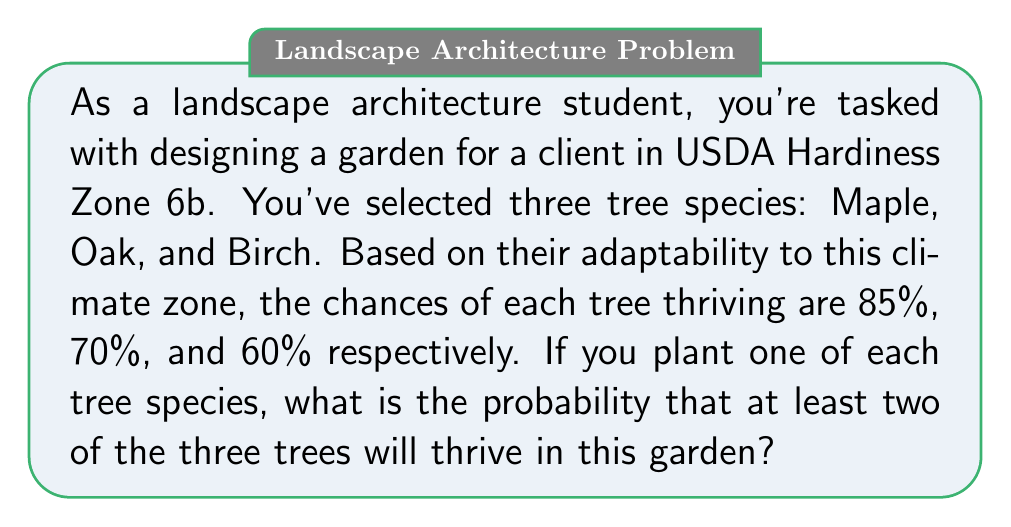Can you solve this math problem? Let's approach this step-by-step:

1) First, we need to calculate the probability of at least two trees thriving. It's easier to calculate this by subtracting the probability of 0 or 1 tree thriving from 1.

2) Let's define our events:
   M: Maple thrives
   O: Oak thrives
   B: Birch thrives

3) Probabilities:
   P(M) = 0.85
   P(O) = 0.70
   P(B) = 0.60

4) To calculate the probability of 0 or 1 tree thriving, we need:
   P(none thrive) + P(only Maple) + P(only Oak) + P(only Birch)

5) P(none thrive) = P(not M and not O and not B)
   $$ P(\text{none}) = (1-0.85)(1-0.70)(1-0.60) = 0.15 \times 0.30 \times 0.40 = 0.018 $$

6) P(only Maple) = P(M and not O and not B)
   $$ P(\text{only M}) = 0.85 \times 0.30 \times 0.40 = 0.102 $$

7) P(only Oak) = P(not M and O and not B)
   $$ P(\text{only O}) = 0.15 \times 0.70 \times 0.40 = 0.042 $$

8) P(only Birch) = P(not M and not O and B)
   $$ P(\text{only B}) = 0.15 \times 0.30 \times 0.60 = 0.027 $$

9) Sum these probabilities:
   $$ P(0 \text{ or } 1 \text{ thrive}) = 0.018 + 0.102 + 0.042 + 0.027 = 0.189 $$

10) Therefore, the probability of at least 2 thriving is:
    $$ P(\text{at least 2 thrive}) = 1 - P(0 \text{ or } 1 \text{ thrive}) = 1 - 0.189 = 0.811 $$
Answer: 0.811 or 81.1% 